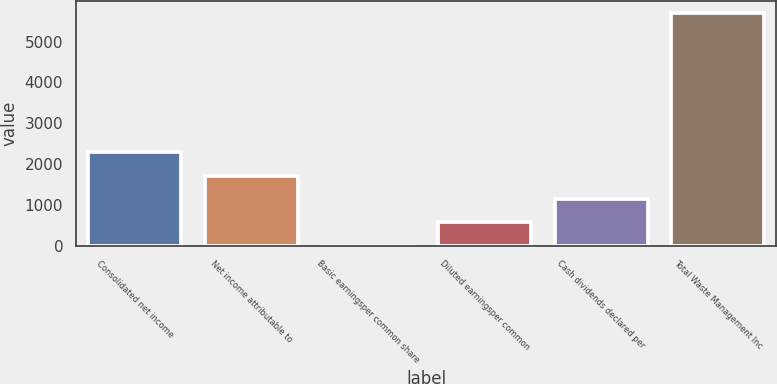Convert chart. <chart><loc_0><loc_0><loc_500><loc_500><bar_chart><fcel>Consolidated net income<fcel>Net income attributable to<fcel>Basic earningsper common share<fcel>Diluted earningsper common<fcel>Cash dividends declared per<fcel>Total Waste Management Inc<nl><fcel>2282.93<fcel>1712.25<fcel>0.21<fcel>570.89<fcel>1141.57<fcel>5707<nl></chart> 